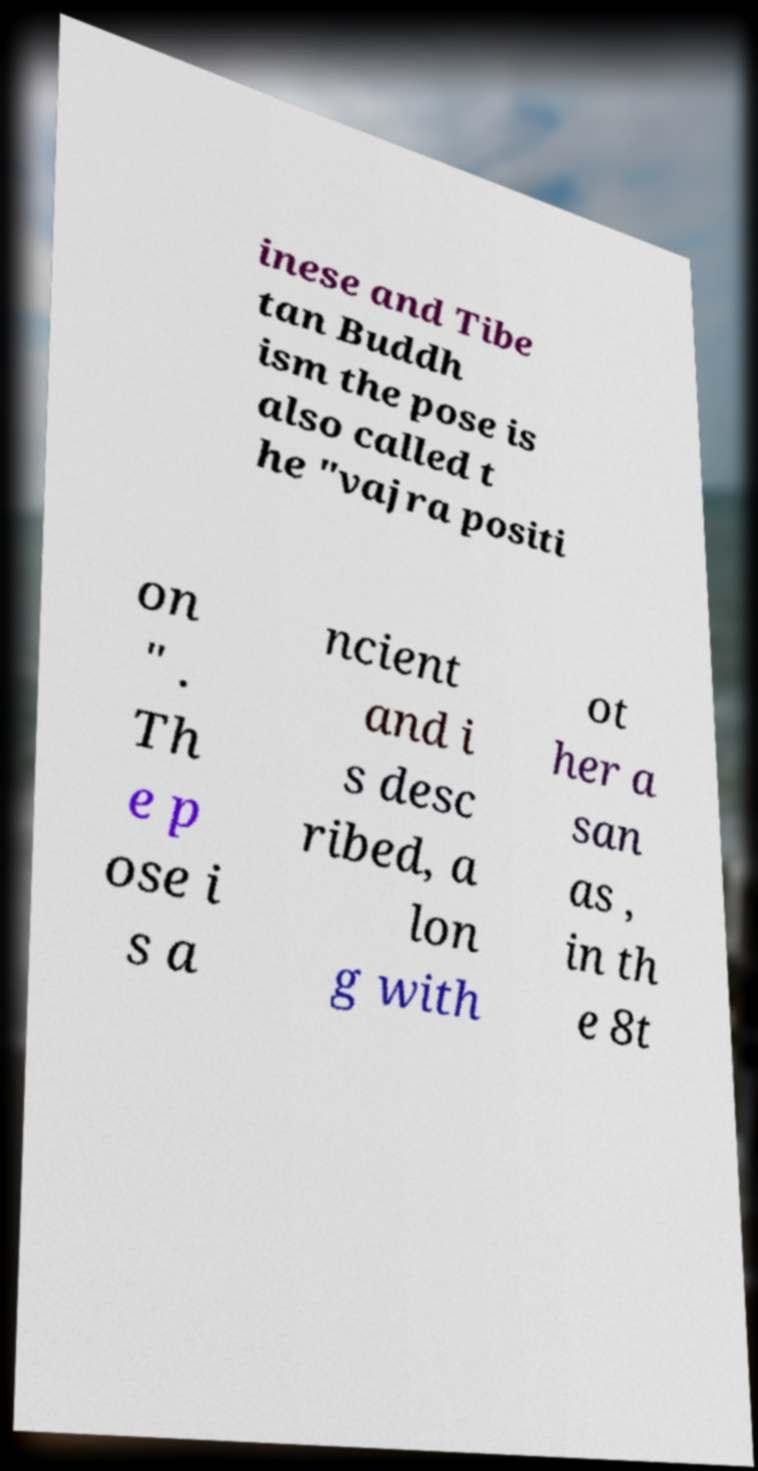Please read and relay the text visible in this image. What does it say? inese and Tibe tan Buddh ism the pose is also called t he "vajra positi on " . Th e p ose i s a ncient and i s desc ribed, a lon g with ot her a san as , in th e 8t 